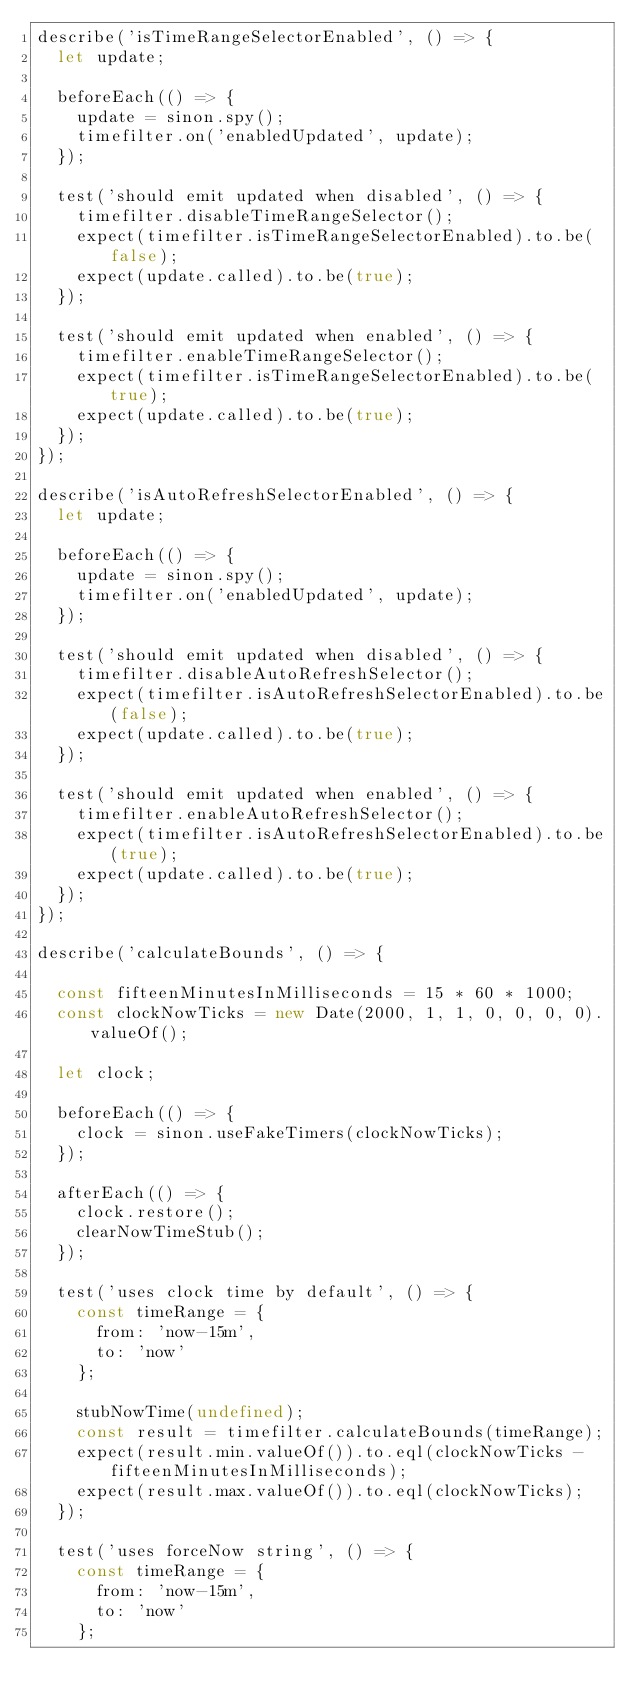<code> <loc_0><loc_0><loc_500><loc_500><_JavaScript_>describe('isTimeRangeSelectorEnabled', () => {
  let update;

  beforeEach(() => {
    update = sinon.spy();
    timefilter.on('enabledUpdated', update);
  });

  test('should emit updated when disabled', () => {
    timefilter.disableTimeRangeSelector();
    expect(timefilter.isTimeRangeSelectorEnabled).to.be(false);
    expect(update.called).to.be(true);
  });

  test('should emit updated when enabled', () => {
    timefilter.enableTimeRangeSelector();
    expect(timefilter.isTimeRangeSelectorEnabled).to.be(true);
    expect(update.called).to.be(true);
  });
});

describe('isAutoRefreshSelectorEnabled', () => {
  let update;

  beforeEach(() => {
    update = sinon.spy();
    timefilter.on('enabledUpdated', update);
  });

  test('should emit updated when disabled', () => {
    timefilter.disableAutoRefreshSelector();
    expect(timefilter.isAutoRefreshSelectorEnabled).to.be(false);
    expect(update.called).to.be(true);
  });

  test('should emit updated when enabled', () => {
    timefilter.enableAutoRefreshSelector();
    expect(timefilter.isAutoRefreshSelectorEnabled).to.be(true);
    expect(update.called).to.be(true);
  });
});

describe('calculateBounds', () => {

  const fifteenMinutesInMilliseconds = 15 * 60 * 1000;
  const clockNowTicks = new Date(2000, 1, 1, 0, 0, 0, 0).valueOf();

  let clock;

  beforeEach(() => {
    clock = sinon.useFakeTimers(clockNowTicks);
  });

  afterEach(() => {
    clock.restore();
    clearNowTimeStub();
  });

  test('uses clock time by default', () => {
    const timeRange = {
      from: 'now-15m',
      to: 'now'
    };

    stubNowTime(undefined);
    const result = timefilter.calculateBounds(timeRange);
    expect(result.min.valueOf()).to.eql(clockNowTicks - fifteenMinutesInMilliseconds);
    expect(result.max.valueOf()).to.eql(clockNowTicks);
  });

  test('uses forceNow string', () => {
    const timeRange = {
      from: 'now-15m',
      to: 'now'
    };
</code> 